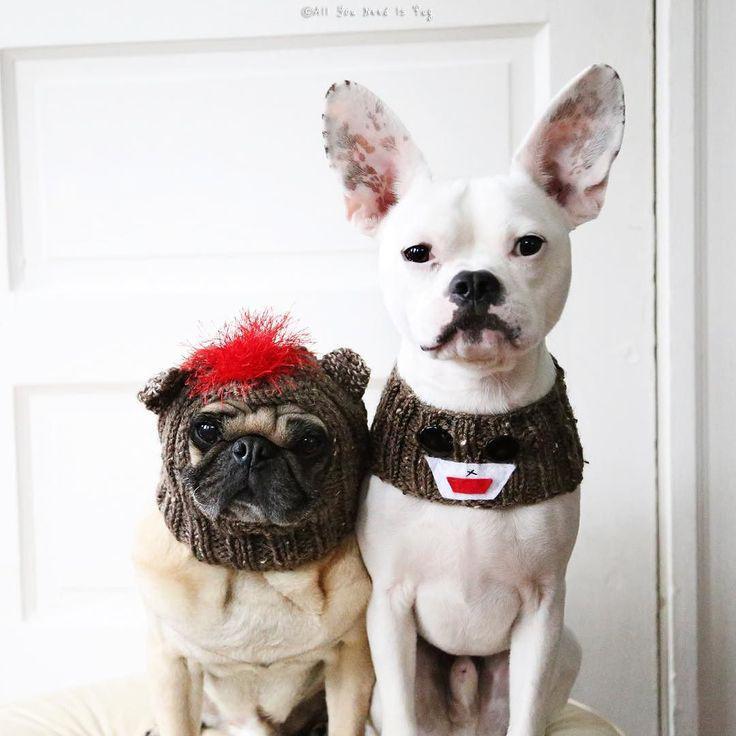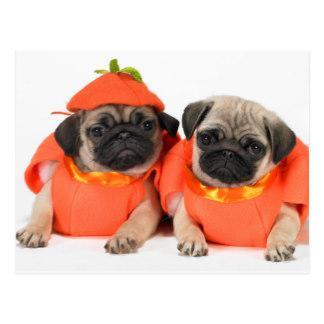The first image is the image on the left, the second image is the image on the right. Examine the images to the left and right. Is the description "There are exactly four dogs in total." accurate? Answer yes or no. Yes. The first image is the image on the left, the second image is the image on the right. For the images shown, is this caption "The combined images include two dogs wearing Santa outfits, including red hats with white pom-poms." true? Answer yes or no. No. 